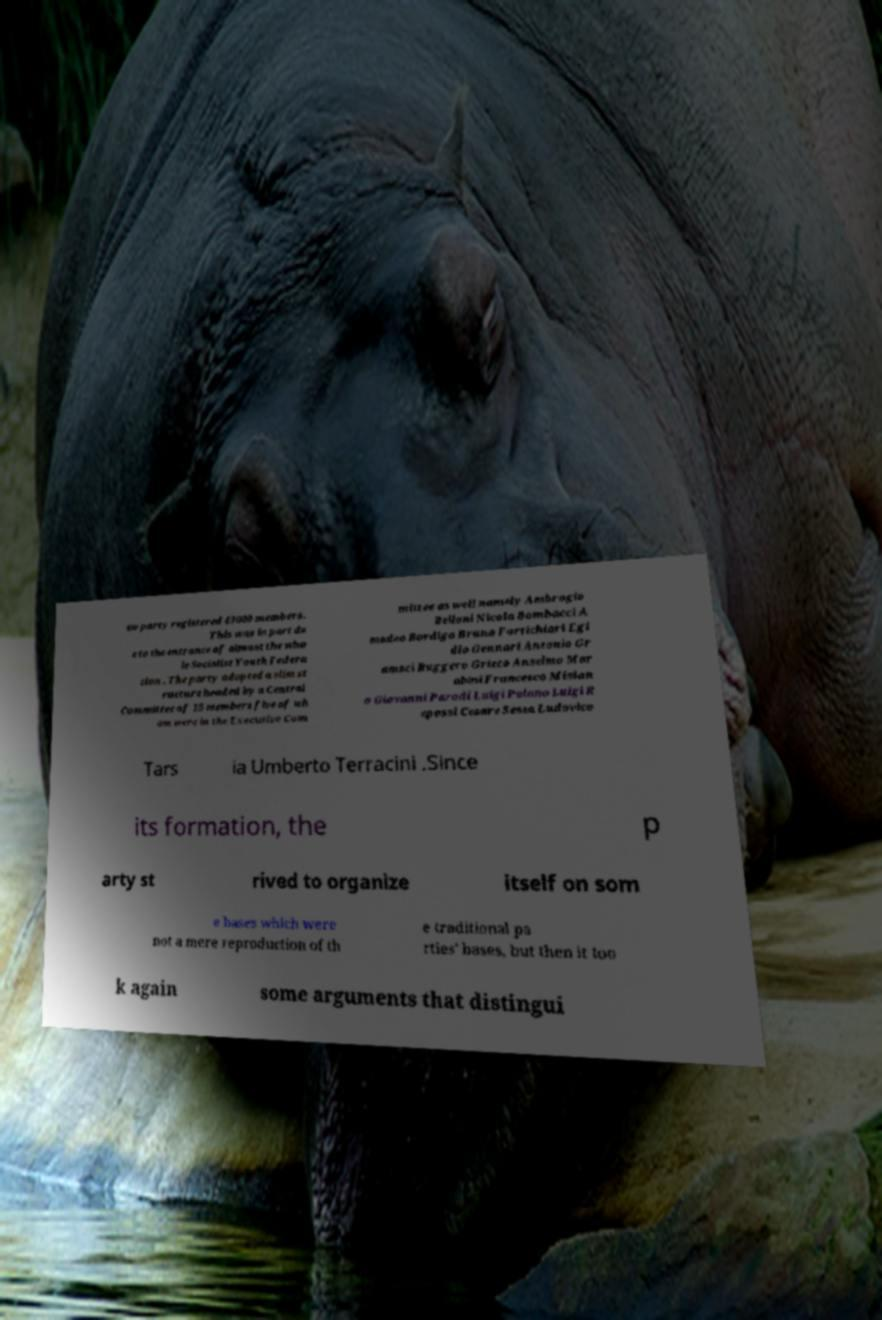Please identify and transcribe the text found in this image. ew party registered 43000 members. This was in part du e to the entrance of almost the who le Socialist Youth Federa tion . The party adopted a slim st ructure headed by a Central Committee of 15 members five of wh om were in the Executive Com mittee as well namely Ambrogio Belloni Nicola Bombacci A madeo Bordiga Bruno Fortichiari Egi dio Gennari Antonio Gr amsci Ruggero Grieco Anselmo Mar abini Francesco Misian o Giovanni Parodi Luigi Polano Luigi R epossi Cesare Sessa Ludovico Tars ia Umberto Terracini .Since its formation, the p arty st rived to organize itself on som e bases which were not a mere reproduction of th e traditional pa rties' bases, but then it too k again some arguments that distingui 